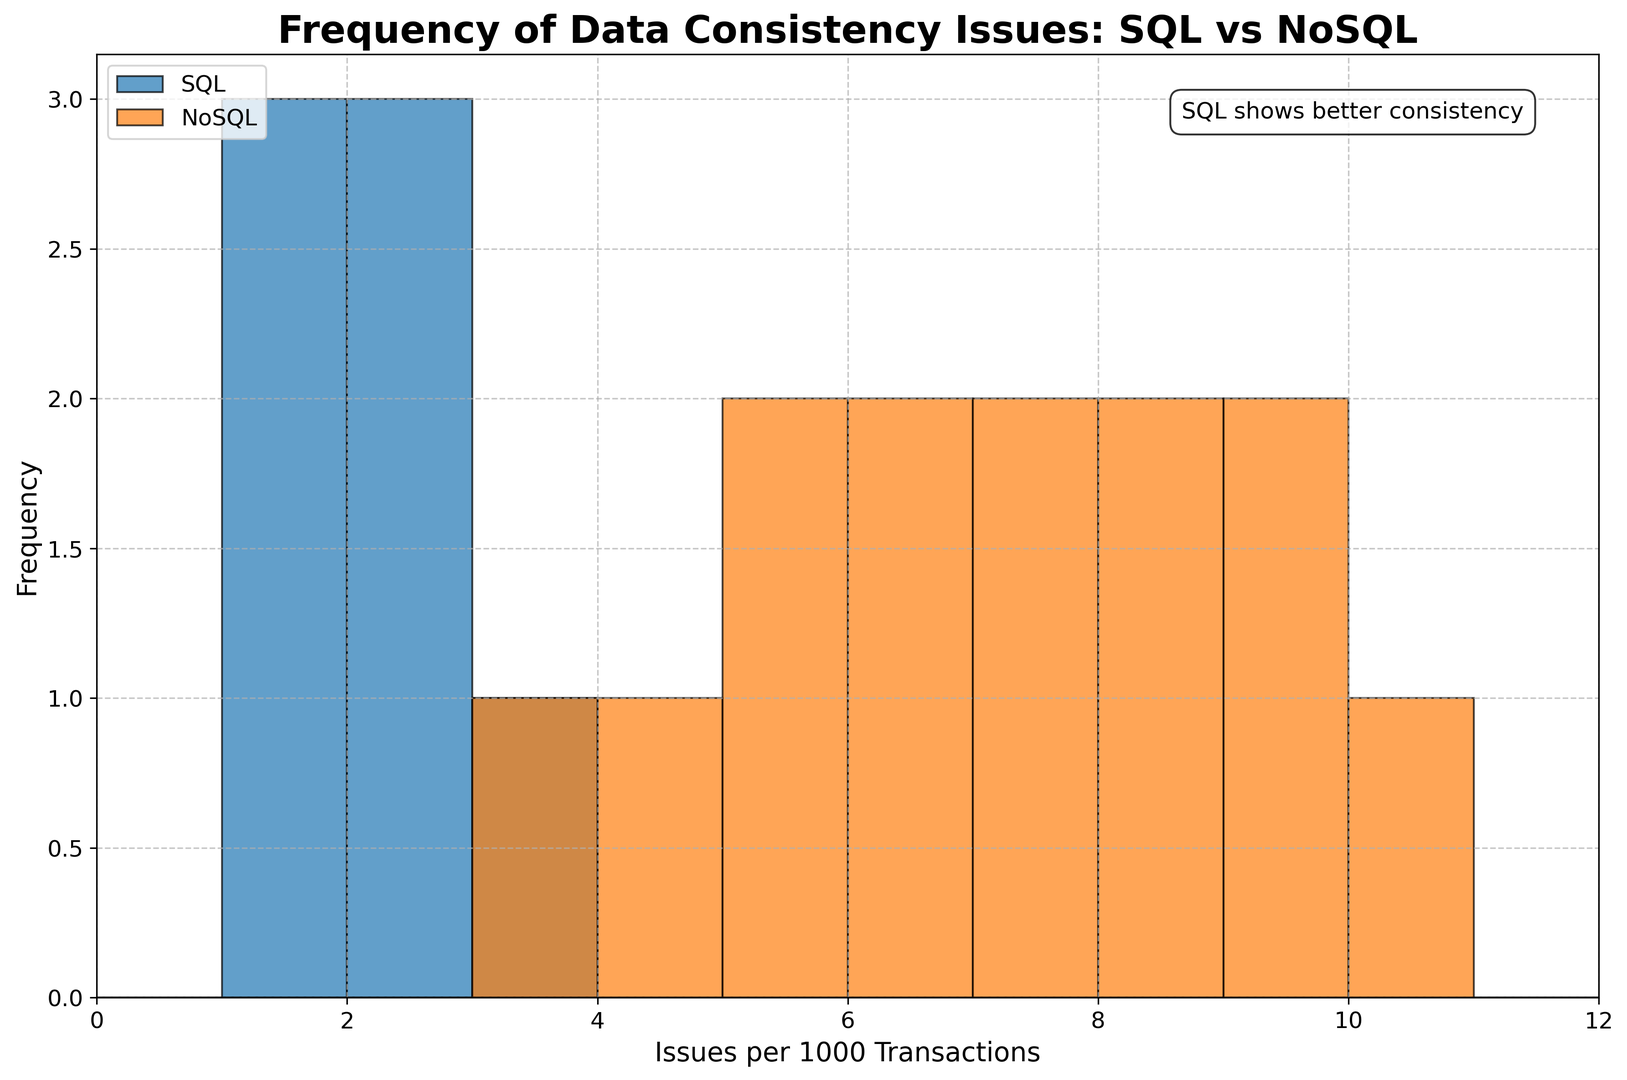Which database type has fewer data consistency issues per 1000 transactions on average? We consider the two groups separately: SQL and NoSQL. SQL has values 2, 3, 1, 2, 1, 2, 1. The average is (2+3+1+2+1+2+1)/7 = 1.71. For NoSQL, the values are 8, 7, 9, 6, 5, 4, 7, 8, 9, 10, 5, 6, 3. The average is (8+7+9+6+5+4+7+8+9+10+5+6+3)/13 = 6.62.
Answer: SQL Which NoSQL database type shows the highest frequency of data consistency issues? We look at the values corresponding to each NoSQL type: MongoDB (8, 7, 9), Cassandra (7, 8), Couchbase (9, 10), Redis (6, 5), DynamoDB (5, 6), Neo4j (4, 3). The highest value is in Couchbase (10).
Answer: Couchbase Is there any overlap in the frequency of data consistency issues between SQL and NoSQL databases? We compare the frequency ranges: SQL ranges from 1 to 3. NoSQL ranges from 3 to 10. The overlap is at 3.
Answer: Yes What is the frequency range of data consistency issues in NoSQL databases? We look at the minimum and maximum values for all NoSQL database types: (8, 7, 9, 7, 8, 9, 10, 6, 5, 4, 5, 6, 3). The minimum is 3 and the maximum is 10.
Answer: 3 to 10 Which database type shows the most consistent (least variable) data consistency issues per 1000 transactions? We compare the variability of the data points. SQL values: 2, 3, 1, 2, 1, 2, 1. The range is 3-1 = 2. NoSQL values: 8, 7, 9, 6, 5, 4, 7, 8, 9, 10, 5, 6, 3. The range is 10-3 = 7. SQL has a smaller range, so it is more consistent.
Answer: SQL 